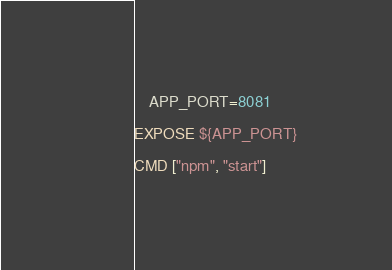<code> <loc_0><loc_0><loc_500><loc_500><_Dockerfile_>    APP_PORT=8081

EXPOSE ${APP_PORT}

CMD ["npm", "start"]
</code> 